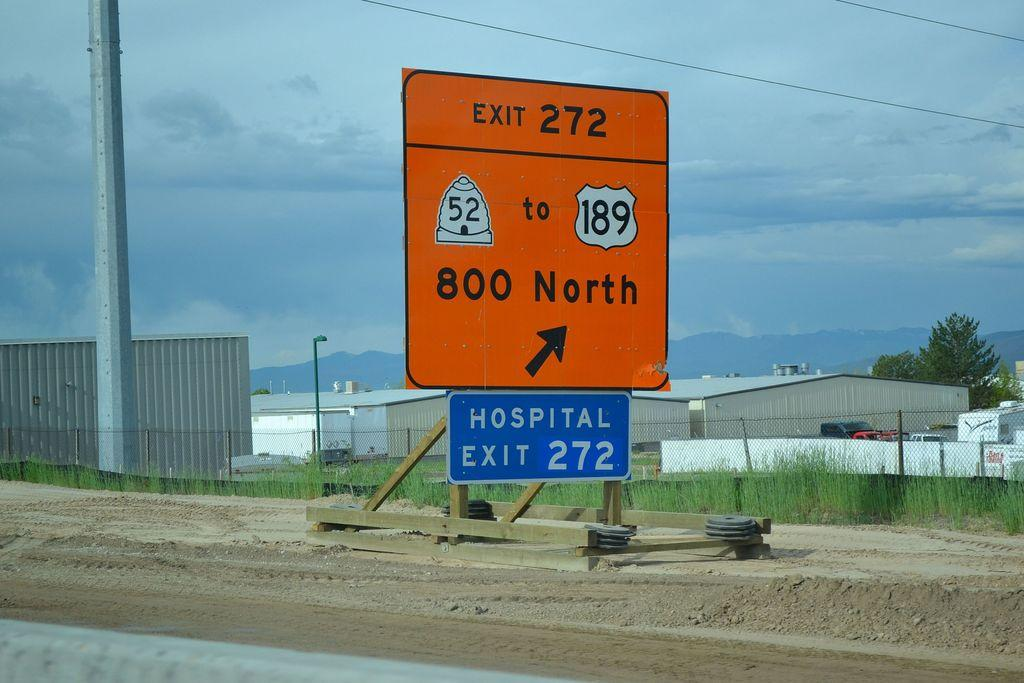<image>
Create a compact narrative representing the image presented. A street sign with the words 800 North and an arrow. 